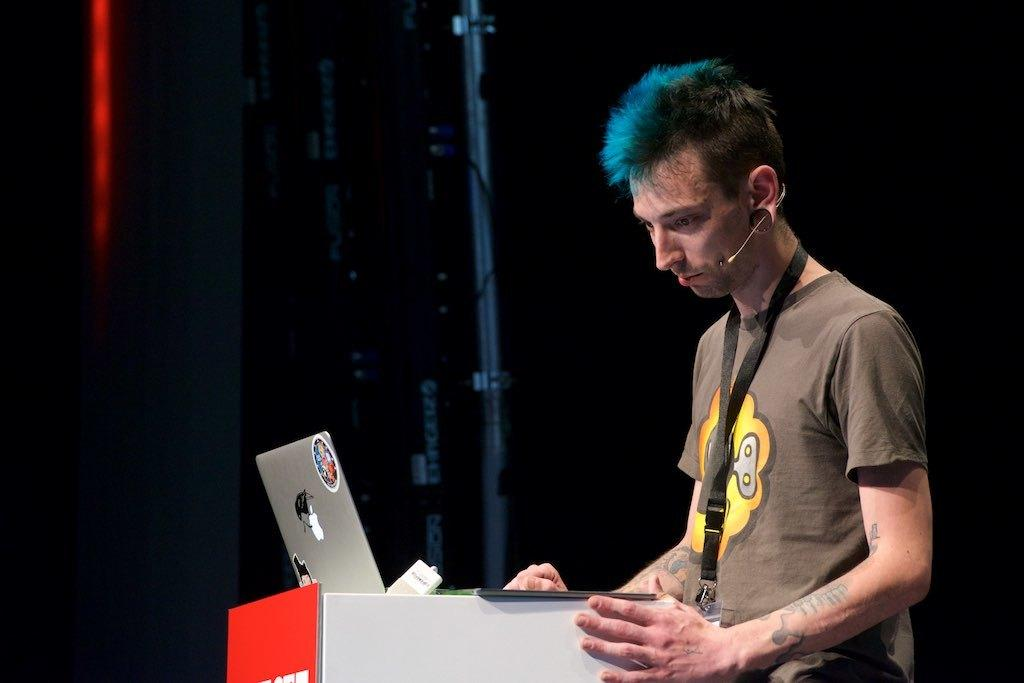Who is the main subject in the image? There is a boy in the image. Where is the boy located in the image? The boy is on the right side of the image. What object is in front of the boy on a desk? There is a laptop in front of the boy on a desk. What can be seen in the background of the image? There is a rod in the background of the image. What type of chess piece is the boy holding in the image? There is no chess piece present in the image. Is the boy on a swing in the image? No, the boy is not on a swing in the image; he is on the right side of the image. 